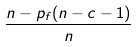Convert formula to latex. <formula><loc_0><loc_0><loc_500><loc_500>\frac { n - p _ { f } ( n - c - 1 ) } { n }</formula> 